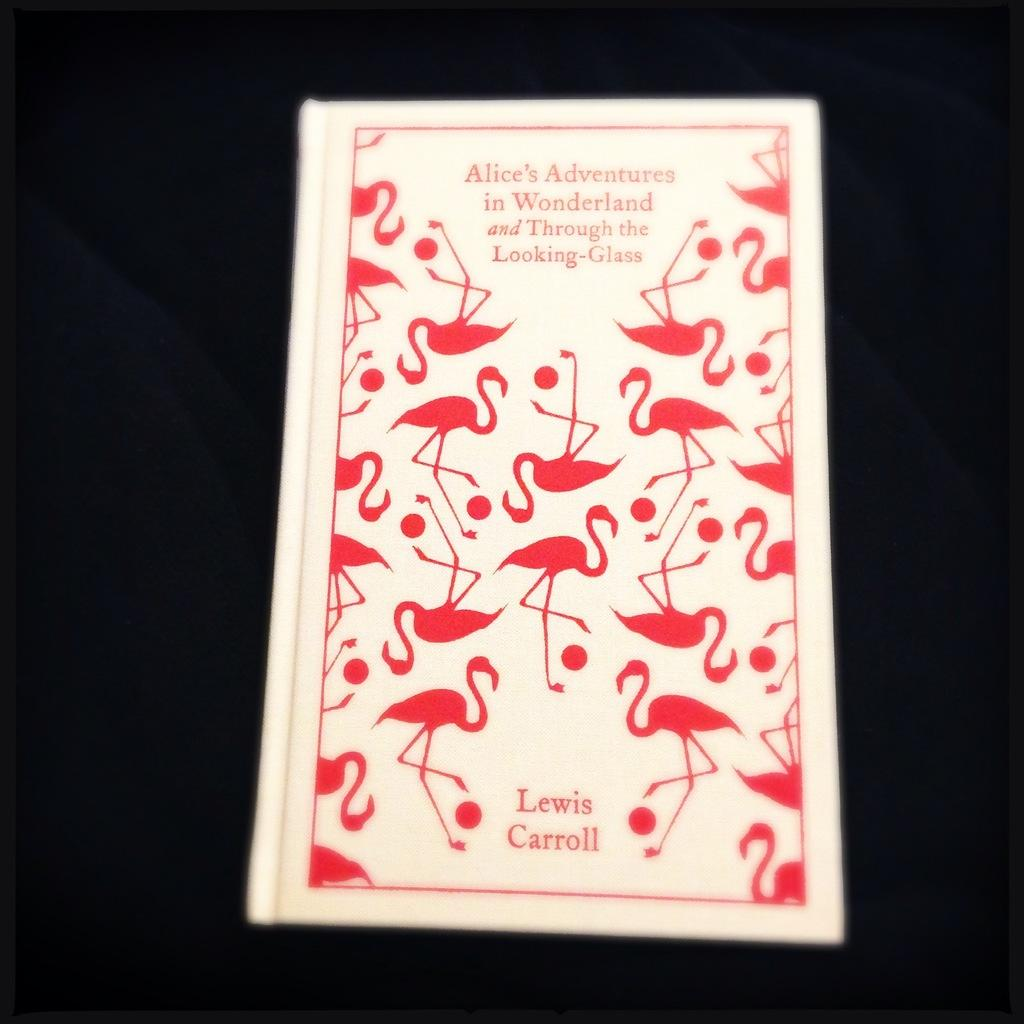<image>
Describe the image concisely. The book shown was written by the author Lewis Carroll. 